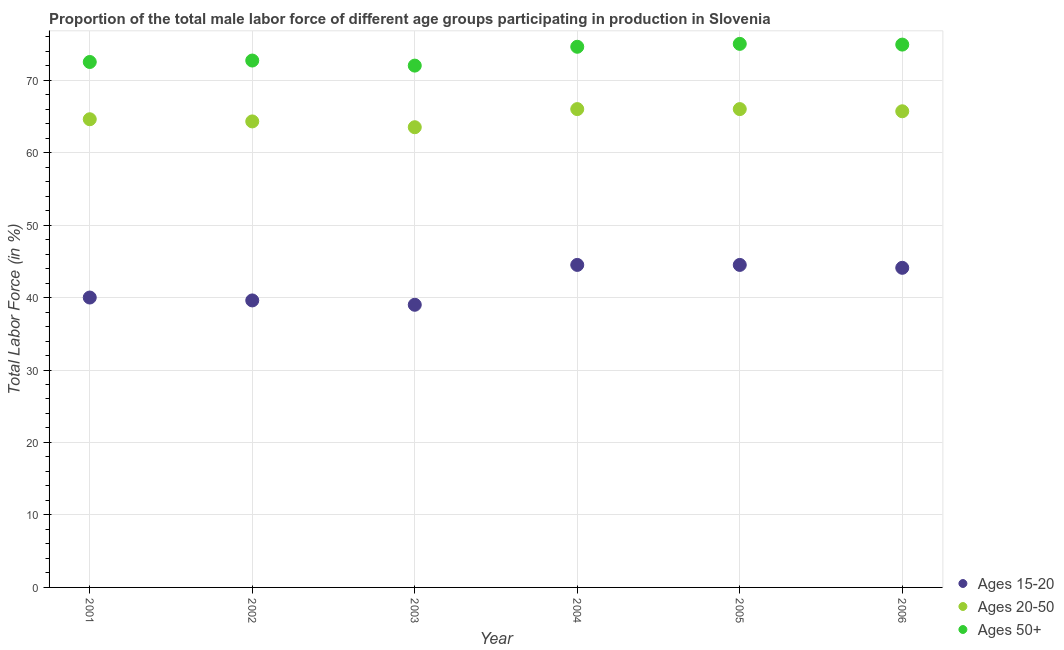How many different coloured dotlines are there?
Ensure brevity in your answer.  3. Is the number of dotlines equal to the number of legend labels?
Your answer should be compact. Yes. What is the percentage of male labor force within the age group 15-20 in 2003?
Offer a terse response. 39. Across all years, what is the maximum percentage of male labor force within the age group 15-20?
Offer a terse response. 44.5. Across all years, what is the minimum percentage of male labor force within the age group 15-20?
Make the answer very short. 39. In which year was the percentage of male labor force above age 50 minimum?
Offer a terse response. 2003. What is the total percentage of male labor force within the age group 15-20 in the graph?
Keep it short and to the point. 251.7. What is the difference between the percentage of male labor force within the age group 15-20 in 2001 and the percentage of male labor force above age 50 in 2006?
Provide a short and direct response. -34.9. What is the average percentage of male labor force within the age group 20-50 per year?
Make the answer very short. 65.02. In the year 2006, what is the difference between the percentage of male labor force above age 50 and percentage of male labor force within the age group 15-20?
Keep it short and to the point. 30.8. What is the ratio of the percentage of male labor force within the age group 15-20 in 2002 to that in 2003?
Make the answer very short. 1.02. Is the percentage of male labor force within the age group 20-50 in 2004 less than that in 2006?
Provide a short and direct response. No. Is the difference between the percentage of male labor force within the age group 15-20 in 2002 and 2005 greater than the difference between the percentage of male labor force above age 50 in 2002 and 2005?
Provide a short and direct response. No. What is the difference between the highest and the second highest percentage of male labor force within the age group 20-50?
Provide a short and direct response. 0. What is the difference between the highest and the lowest percentage of male labor force within the age group 15-20?
Give a very brief answer. 5.5. In how many years, is the percentage of male labor force above age 50 greater than the average percentage of male labor force above age 50 taken over all years?
Your answer should be compact. 3. Does the percentage of male labor force within the age group 15-20 monotonically increase over the years?
Your answer should be compact. No. Is the percentage of male labor force within the age group 20-50 strictly greater than the percentage of male labor force within the age group 15-20 over the years?
Offer a very short reply. Yes. How many dotlines are there?
Your response must be concise. 3. How many years are there in the graph?
Offer a terse response. 6. Are the values on the major ticks of Y-axis written in scientific E-notation?
Make the answer very short. No. Does the graph contain any zero values?
Provide a succinct answer. No. Does the graph contain grids?
Your answer should be very brief. Yes. How many legend labels are there?
Provide a short and direct response. 3. How are the legend labels stacked?
Offer a terse response. Vertical. What is the title of the graph?
Give a very brief answer. Proportion of the total male labor force of different age groups participating in production in Slovenia. Does "Male employers" appear as one of the legend labels in the graph?
Make the answer very short. No. What is the label or title of the X-axis?
Give a very brief answer. Year. What is the label or title of the Y-axis?
Provide a succinct answer. Total Labor Force (in %). What is the Total Labor Force (in %) in Ages 20-50 in 2001?
Your response must be concise. 64.6. What is the Total Labor Force (in %) of Ages 50+ in 2001?
Offer a very short reply. 72.5. What is the Total Labor Force (in %) in Ages 15-20 in 2002?
Provide a short and direct response. 39.6. What is the Total Labor Force (in %) in Ages 20-50 in 2002?
Your answer should be very brief. 64.3. What is the Total Labor Force (in %) of Ages 50+ in 2002?
Keep it short and to the point. 72.7. What is the Total Labor Force (in %) in Ages 20-50 in 2003?
Your response must be concise. 63.5. What is the Total Labor Force (in %) of Ages 50+ in 2003?
Your answer should be very brief. 72. What is the Total Labor Force (in %) in Ages 15-20 in 2004?
Offer a very short reply. 44.5. What is the Total Labor Force (in %) in Ages 20-50 in 2004?
Provide a short and direct response. 66. What is the Total Labor Force (in %) in Ages 50+ in 2004?
Keep it short and to the point. 74.6. What is the Total Labor Force (in %) in Ages 15-20 in 2005?
Your response must be concise. 44.5. What is the Total Labor Force (in %) in Ages 20-50 in 2005?
Your answer should be compact. 66. What is the Total Labor Force (in %) in Ages 15-20 in 2006?
Your answer should be compact. 44.1. What is the Total Labor Force (in %) in Ages 20-50 in 2006?
Offer a terse response. 65.7. What is the Total Labor Force (in %) of Ages 50+ in 2006?
Give a very brief answer. 74.9. Across all years, what is the maximum Total Labor Force (in %) in Ages 15-20?
Your response must be concise. 44.5. Across all years, what is the minimum Total Labor Force (in %) in Ages 20-50?
Give a very brief answer. 63.5. What is the total Total Labor Force (in %) in Ages 15-20 in the graph?
Keep it short and to the point. 251.7. What is the total Total Labor Force (in %) of Ages 20-50 in the graph?
Your response must be concise. 390.1. What is the total Total Labor Force (in %) of Ages 50+ in the graph?
Ensure brevity in your answer.  441.7. What is the difference between the Total Labor Force (in %) in Ages 50+ in 2001 and that in 2002?
Ensure brevity in your answer.  -0.2. What is the difference between the Total Labor Force (in %) in Ages 20-50 in 2001 and that in 2003?
Ensure brevity in your answer.  1.1. What is the difference between the Total Labor Force (in %) of Ages 20-50 in 2001 and that in 2004?
Ensure brevity in your answer.  -1.4. What is the difference between the Total Labor Force (in %) of Ages 15-20 in 2001 and that in 2006?
Ensure brevity in your answer.  -4.1. What is the difference between the Total Labor Force (in %) of Ages 15-20 in 2002 and that in 2003?
Ensure brevity in your answer.  0.6. What is the difference between the Total Labor Force (in %) of Ages 50+ in 2002 and that in 2003?
Provide a succinct answer. 0.7. What is the difference between the Total Labor Force (in %) of Ages 15-20 in 2002 and that in 2004?
Give a very brief answer. -4.9. What is the difference between the Total Labor Force (in %) of Ages 50+ in 2002 and that in 2004?
Offer a terse response. -1.9. What is the difference between the Total Labor Force (in %) in Ages 20-50 in 2002 and that in 2005?
Keep it short and to the point. -1.7. What is the difference between the Total Labor Force (in %) of Ages 20-50 in 2002 and that in 2006?
Your answer should be compact. -1.4. What is the difference between the Total Labor Force (in %) in Ages 50+ in 2002 and that in 2006?
Provide a succinct answer. -2.2. What is the difference between the Total Labor Force (in %) in Ages 20-50 in 2003 and that in 2004?
Your answer should be very brief. -2.5. What is the difference between the Total Labor Force (in %) of Ages 15-20 in 2003 and that in 2005?
Keep it short and to the point. -5.5. What is the difference between the Total Labor Force (in %) in Ages 20-50 in 2003 and that in 2005?
Your answer should be very brief. -2.5. What is the difference between the Total Labor Force (in %) of Ages 50+ in 2004 and that in 2006?
Provide a short and direct response. -0.3. What is the difference between the Total Labor Force (in %) in Ages 20-50 in 2005 and that in 2006?
Provide a short and direct response. 0.3. What is the difference between the Total Labor Force (in %) in Ages 15-20 in 2001 and the Total Labor Force (in %) in Ages 20-50 in 2002?
Offer a very short reply. -24.3. What is the difference between the Total Labor Force (in %) in Ages 15-20 in 2001 and the Total Labor Force (in %) in Ages 50+ in 2002?
Offer a very short reply. -32.7. What is the difference between the Total Labor Force (in %) of Ages 20-50 in 2001 and the Total Labor Force (in %) of Ages 50+ in 2002?
Your response must be concise. -8.1. What is the difference between the Total Labor Force (in %) in Ages 15-20 in 2001 and the Total Labor Force (in %) in Ages 20-50 in 2003?
Your response must be concise. -23.5. What is the difference between the Total Labor Force (in %) in Ages 15-20 in 2001 and the Total Labor Force (in %) in Ages 50+ in 2003?
Your response must be concise. -32. What is the difference between the Total Labor Force (in %) in Ages 15-20 in 2001 and the Total Labor Force (in %) in Ages 50+ in 2004?
Ensure brevity in your answer.  -34.6. What is the difference between the Total Labor Force (in %) of Ages 15-20 in 2001 and the Total Labor Force (in %) of Ages 50+ in 2005?
Make the answer very short. -35. What is the difference between the Total Labor Force (in %) of Ages 20-50 in 2001 and the Total Labor Force (in %) of Ages 50+ in 2005?
Keep it short and to the point. -10.4. What is the difference between the Total Labor Force (in %) in Ages 15-20 in 2001 and the Total Labor Force (in %) in Ages 20-50 in 2006?
Make the answer very short. -25.7. What is the difference between the Total Labor Force (in %) of Ages 15-20 in 2001 and the Total Labor Force (in %) of Ages 50+ in 2006?
Provide a succinct answer. -34.9. What is the difference between the Total Labor Force (in %) in Ages 15-20 in 2002 and the Total Labor Force (in %) in Ages 20-50 in 2003?
Keep it short and to the point. -23.9. What is the difference between the Total Labor Force (in %) in Ages 15-20 in 2002 and the Total Labor Force (in %) in Ages 50+ in 2003?
Provide a succinct answer. -32.4. What is the difference between the Total Labor Force (in %) of Ages 20-50 in 2002 and the Total Labor Force (in %) of Ages 50+ in 2003?
Provide a succinct answer. -7.7. What is the difference between the Total Labor Force (in %) in Ages 15-20 in 2002 and the Total Labor Force (in %) in Ages 20-50 in 2004?
Your response must be concise. -26.4. What is the difference between the Total Labor Force (in %) of Ages 15-20 in 2002 and the Total Labor Force (in %) of Ages 50+ in 2004?
Your response must be concise. -35. What is the difference between the Total Labor Force (in %) in Ages 15-20 in 2002 and the Total Labor Force (in %) in Ages 20-50 in 2005?
Your answer should be compact. -26.4. What is the difference between the Total Labor Force (in %) in Ages 15-20 in 2002 and the Total Labor Force (in %) in Ages 50+ in 2005?
Your response must be concise. -35.4. What is the difference between the Total Labor Force (in %) of Ages 15-20 in 2002 and the Total Labor Force (in %) of Ages 20-50 in 2006?
Keep it short and to the point. -26.1. What is the difference between the Total Labor Force (in %) in Ages 15-20 in 2002 and the Total Labor Force (in %) in Ages 50+ in 2006?
Your response must be concise. -35.3. What is the difference between the Total Labor Force (in %) in Ages 15-20 in 2003 and the Total Labor Force (in %) in Ages 20-50 in 2004?
Your answer should be compact. -27. What is the difference between the Total Labor Force (in %) of Ages 15-20 in 2003 and the Total Labor Force (in %) of Ages 50+ in 2004?
Your response must be concise. -35.6. What is the difference between the Total Labor Force (in %) in Ages 15-20 in 2003 and the Total Labor Force (in %) in Ages 50+ in 2005?
Your response must be concise. -36. What is the difference between the Total Labor Force (in %) in Ages 20-50 in 2003 and the Total Labor Force (in %) in Ages 50+ in 2005?
Provide a short and direct response. -11.5. What is the difference between the Total Labor Force (in %) of Ages 15-20 in 2003 and the Total Labor Force (in %) of Ages 20-50 in 2006?
Make the answer very short. -26.7. What is the difference between the Total Labor Force (in %) of Ages 15-20 in 2003 and the Total Labor Force (in %) of Ages 50+ in 2006?
Your response must be concise. -35.9. What is the difference between the Total Labor Force (in %) in Ages 20-50 in 2003 and the Total Labor Force (in %) in Ages 50+ in 2006?
Your answer should be compact. -11.4. What is the difference between the Total Labor Force (in %) in Ages 15-20 in 2004 and the Total Labor Force (in %) in Ages 20-50 in 2005?
Give a very brief answer. -21.5. What is the difference between the Total Labor Force (in %) of Ages 15-20 in 2004 and the Total Labor Force (in %) of Ages 50+ in 2005?
Offer a terse response. -30.5. What is the difference between the Total Labor Force (in %) of Ages 20-50 in 2004 and the Total Labor Force (in %) of Ages 50+ in 2005?
Your answer should be compact. -9. What is the difference between the Total Labor Force (in %) in Ages 15-20 in 2004 and the Total Labor Force (in %) in Ages 20-50 in 2006?
Provide a short and direct response. -21.2. What is the difference between the Total Labor Force (in %) of Ages 15-20 in 2004 and the Total Labor Force (in %) of Ages 50+ in 2006?
Your answer should be very brief. -30.4. What is the difference between the Total Labor Force (in %) in Ages 20-50 in 2004 and the Total Labor Force (in %) in Ages 50+ in 2006?
Make the answer very short. -8.9. What is the difference between the Total Labor Force (in %) in Ages 15-20 in 2005 and the Total Labor Force (in %) in Ages 20-50 in 2006?
Ensure brevity in your answer.  -21.2. What is the difference between the Total Labor Force (in %) of Ages 15-20 in 2005 and the Total Labor Force (in %) of Ages 50+ in 2006?
Your response must be concise. -30.4. What is the average Total Labor Force (in %) in Ages 15-20 per year?
Make the answer very short. 41.95. What is the average Total Labor Force (in %) in Ages 20-50 per year?
Keep it short and to the point. 65.02. What is the average Total Labor Force (in %) of Ages 50+ per year?
Ensure brevity in your answer.  73.62. In the year 2001, what is the difference between the Total Labor Force (in %) in Ages 15-20 and Total Labor Force (in %) in Ages 20-50?
Your answer should be very brief. -24.6. In the year 2001, what is the difference between the Total Labor Force (in %) in Ages 15-20 and Total Labor Force (in %) in Ages 50+?
Provide a short and direct response. -32.5. In the year 2002, what is the difference between the Total Labor Force (in %) in Ages 15-20 and Total Labor Force (in %) in Ages 20-50?
Your response must be concise. -24.7. In the year 2002, what is the difference between the Total Labor Force (in %) in Ages 15-20 and Total Labor Force (in %) in Ages 50+?
Make the answer very short. -33.1. In the year 2002, what is the difference between the Total Labor Force (in %) in Ages 20-50 and Total Labor Force (in %) in Ages 50+?
Offer a terse response. -8.4. In the year 2003, what is the difference between the Total Labor Force (in %) of Ages 15-20 and Total Labor Force (in %) of Ages 20-50?
Ensure brevity in your answer.  -24.5. In the year 2003, what is the difference between the Total Labor Force (in %) of Ages 15-20 and Total Labor Force (in %) of Ages 50+?
Provide a succinct answer. -33. In the year 2004, what is the difference between the Total Labor Force (in %) in Ages 15-20 and Total Labor Force (in %) in Ages 20-50?
Your response must be concise. -21.5. In the year 2004, what is the difference between the Total Labor Force (in %) in Ages 15-20 and Total Labor Force (in %) in Ages 50+?
Provide a short and direct response. -30.1. In the year 2004, what is the difference between the Total Labor Force (in %) of Ages 20-50 and Total Labor Force (in %) of Ages 50+?
Provide a short and direct response. -8.6. In the year 2005, what is the difference between the Total Labor Force (in %) in Ages 15-20 and Total Labor Force (in %) in Ages 20-50?
Ensure brevity in your answer.  -21.5. In the year 2005, what is the difference between the Total Labor Force (in %) of Ages 15-20 and Total Labor Force (in %) of Ages 50+?
Provide a succinct answer. -30.5. In the year 2005, what is the difference between the Total Labor Force (in %) in Ages 20-50 and Total Labor Force (in %) in Ages 50+?
Offer a terse response. -9. In the year 2006, what is the difference between the Total Labor Force (in %) of Ages 15-20 and Total Labor Force (in %) of Ages 20-50?
Provide a succinct answer. -21.6. In the year 2006, what is the difference between the Total Labor Force (in %) of Ages 15-20 and Total Labor Force (in %) of Ages 50+?
Offer a terse response. -30.8. In the year 2006, what is the difference between the Total Labor Force (in %) of Ages 20-50 and Total Labor Force (in %) of Ages 50+?
Your response must be concise. -9.2. What is the ratio of the Total Labor Force (in %) of Ages 15-20 in 2001 to that in 2002?
Make the answer very short. 1.01. What is the ratio of the Total Labor Force (in %) in Ages 20-50 in 2001 to that in 2002?
Your answer should be very brief. 1. What is the ratio of the Total Labor Force (in %) of Ages 15-20 in 2001 to that in 2003?
Your response must be concise. 1.03. What is the ratio of the Total Labor Force (in %) in Ages 20-50 in 2001 to that in 2003?
Provide a succinct answer. 1.02. What is the ratio of the Total Labor Force (in %) of Ages 15-20 in 2001 to that in 2004?
Provide a succinct answer. 0.9. What is the ratio of the Total Labor Force (in %) in Ages 20-50 in 2001 to that in 2004?
Provide a succinct answer. 0.98. What is the ratio of the Total Labor Force (in %) in Ages 50+ in 2001 to that in 2004?
Your response must be concise. 0.97. What is the ratio of the Total Labor Force (in %) of Ages 15-20 in 2001 to that in 2005?
Give a very brief answer. 0.9. What is the ratio of the Total Labor Force (in %) of Ages 20-50 in 2001 to that in 2005?
Your answer should be compact. 0.98. What is the ratio of the Total Labor Force (in %) of Ages 50+ in 2001 to that in 2005?
Your answer should be very brief. 0.97. What is the ratio of the Total Labor Force (in %) in Ages 15-20 in 2001 to that in 2006?
Provide a short and direct response. 0.91. What is the ratio of the Total Labor Force (in %) of Ages 20-50 in 2001 to that in 2006?
Give a very brief answer. 0.98. What is the ratio of the Total Labor Force (in %) in Ages 50+ in 2001 to that in 2006?
Your answer should be very brief. 0.97. What is the ratio of the Total Labor Force (in %) of Ages 15-20 in 2002 to that in 2003?
Make the answer very short. 1.02. What is the ratio of the Total Labor Force (in %) in Ages 20-50 in 2002 to that in 2003?
Keep it short and to the point. 1.01. What is the ratio of the Total Labor Force (in %) of Ages 50+ in 2002 to that in 2003?
Ensure brevity in your answer.  1.01. What is the ratio of the Total Labor Force (in %) in Ages 15-20 in 2002 to that in 2004?
Give a very brief answer. 0.89. What is the ratio of the Total Labor Force (in %) of Ages 20-50 in 2002 to that in 2004?
Ensure brevity in your answer.  0.97. What is the ratio of the Total Labor Force (in %) in Ages 50+ in 2002 to that in 2004?
Make the answer very short. 0.97. What is the ratio of the Total Labor Force (in %) in Ages 15-20 in 2002 to that in 2005?
Provide a short and direct response. 0.89. What is the ratio of the Total Labor Force (in %) of Ages 20-50 in 2002 to that in 2005?
Offer a very short reply. 0.97. What is the ratio of the Total Labor Force (in %) in Ages 50+ in 2002 to that in 2005?
Your response must be concise. 0.97. What is the ratio of the Total Labor Force (in %) in Ages 15-20 in 2002 to that in 2006?
Your answer should be very brief. 0.9. What is the ratio of the Total Labor Force (in %) in Ages 20-50 in 2002 to that in 2006?
Make the answer very short. 0.98. What is the ratio of the Total Labor Force (in %) of Ages 50+ in 2002 to that in 2006?
Provide a short and direct response. 0.97. What is the ratio of the Total Labor Force (in %) of Ages 15-20 in 2003 to that in 2004?
Offer a terse response. 0.88. What is the ratio of the Total Labor Force (in %) in Ages 20-50 in 2003 to that in 2004?
Make the answer very short. 0.96. What is the ratio of the Total Labor Force (in %) of Ages 50+ in 2003 to that in 2004?
Keep it short and to the point. 0.97. What is the ratio of the Total Labor Force (in %) of Ages 15-20 in 2003 to that in 2005?
Offer a very short reply. 0.88. What is the ratio of the Total Labor Force (in %) of Ages 20-50 in 2003 to that in 2005?
Give a very brief answer. 0.96. What is the ratio of the Total Labor Force (in %) of Ages 15-20 in 2003 to that in 2006?
Offer a terse response. 0.88. What is the ratio of the Total Labor Force (in %) in Ages 20-50 in 2003 to that in 2006?
Provide a succinct answer. 0.97. What is the ratio of the Total Labor Force (in %) in Ages 50+ in 2003 to that in 2006?
Your response must be concise. 0.96. What is the ratio of the Total Labor Force (in %) in Ages 20-50 in 2004 to that in 2005?
Your answer should be very brief. 1. What is the ratio of the Total Labor Force (in %) of Ages 50+ in 2004 to that in 2005?
Offer a very short reply. 0.99. What is the ratio of the Total Labor Force (in %) in Ages 15-20 in 2004 to that in 2006?
Offer a terse response. 1.01. What is the ratio of the Total Labor Force (in %) in Ages 20-50 in 2004 to that in 2006?
Provide a succinct answer. 1. What is the ratio of the Total Labor Force (in %) in Ages 15-20 in 2005 to that in 2006?
Keep it short and to the point. 1.01. What is the ratio of the Total Labor Force (in %) of Ages 20-50 in 2005 to that in 2006?
Provide a short and direct response. 1. What is the ratio of the Total Labor Force (in %) of Ages 50+ in 2005 to that in 2006?
Ensure brevity in your answer.  1. What is the difference between the highest and the second highest Total Labor Force (in %) in Ages 20-50?
Provide a succinct answer. 0. What is the difference between the highest and the second highest Total Labor Force (in %) of Ages 50+?
Your answer should be very brief. 0.1. What is the difference between the highest and the lowest Total Labor Force (in %) in Ages 20-50?
Offer a very short reply. 2.5. What is the difference between the highest and the lowest Total Labor Force (in %) in Ages 50+?
Keep it short and to the point. 3. 